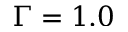Convert formula to latex. <formula><loc_0><loc_0><loc_500><loc_500>\Gamma = 1 . 0</formula> 